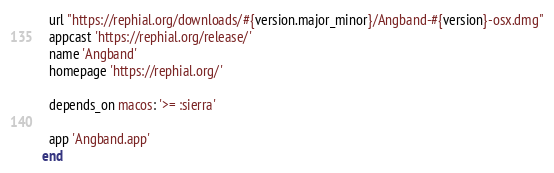<code> <loc_0><loc_0><loc_500><loc_500><_Ruby_>  url "https://rephial.org/downloads/#{version.major_minor}/Angband-#{version}-osx.dmg"
  appcast 'https://rephial.org/release/'
  name 'Angband'
  homepage 'https://rephial.org/'

  depends_on macos: '>= :sierra'

  app 'Angband.app'
end
</code> 